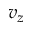<formula> <loc_0><loc_0><loc_500><loc_500>v _ { z }</formula> 